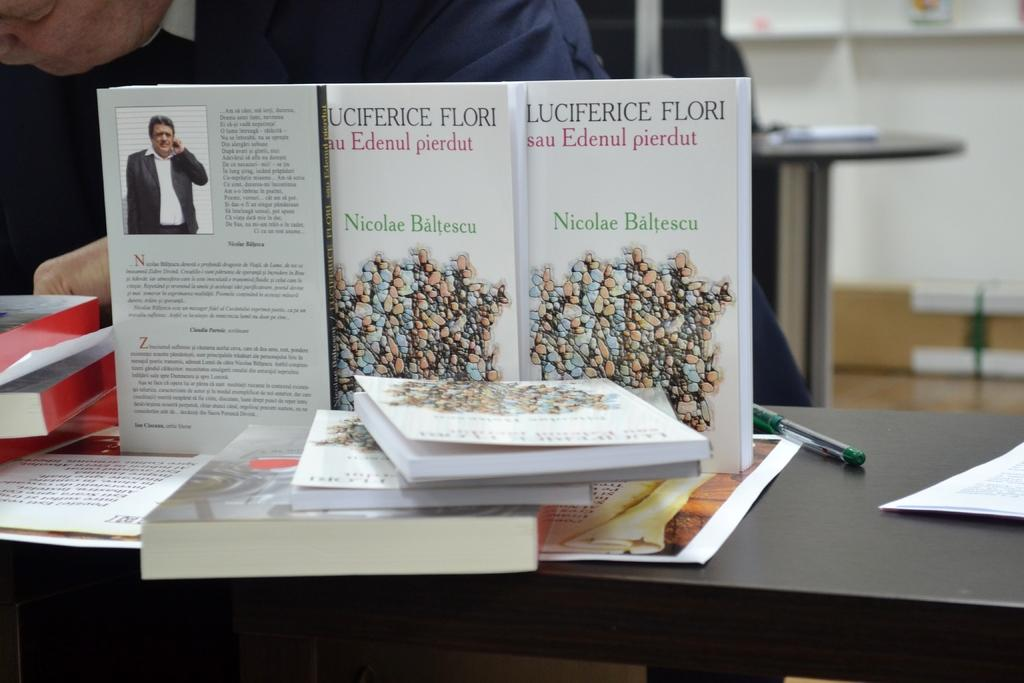Provide a one-sentence caption for the provided image. a book that has the name Nicolae on the cover. 